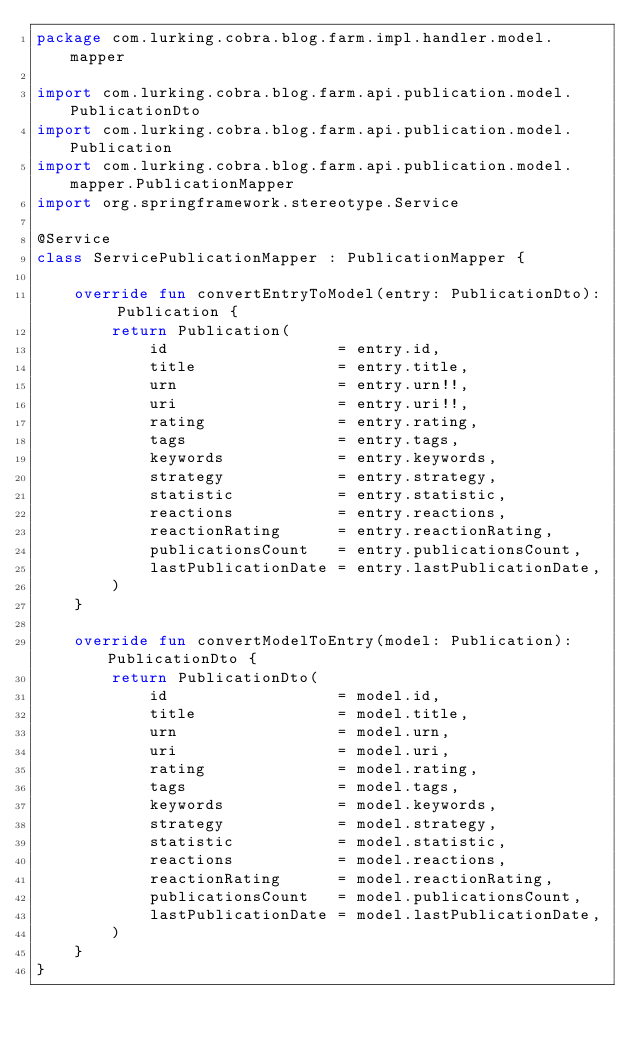<code> <loc_0><loc_0><loc_500><loc_500><_Kotlin_>package com.lurking.cobra.blog.farm.impl.handler.model.mapper

import com.lurking.cobra.blog.farm.api.publication.model.PublicationDto
import com.lurking.cobra.blog.farm.api.publication.model.Publication
import com.lurking.cobra.blog.farm.api.publication.model.mapper.PublicationMapper
import org.springframework.stereotype.Service

@Service
class ServicePublicationMapper : PublicationMapper {

    override fun convertEntryToModel(entry: PublicationDto): Publication {
        return Publication(
            id                  = entry.id,
            title               = entry.title,
            urn                 = entry.urn!!,
            uri                 = entry.uri!!,
            rating              = entry.rating,
            tags                = entry.tags,
            keywords            = entry.keywords,
            strategy            = entry.strategy,
            statistic           = entry.statistic,
            reactions           = entry.reactions,
            reactionRating      = entry.reactionRating,
            publicationsCount   = entry.publicationsCount,
            lastPublicationDate = entry.lastPublicationDate,
        )
    }

    override fun convertModelToEntry(model: Publication): PublicationDto {
        return PublicationDto(
            id                  = model.id,
            title               = model.title,
            urn                 = model.urn,
            uri                 = model.uri,
            rating              = model.rating,
            tags                = model.tags,
            keywords            = model.keywords,
            strategy            = model.strategy,
            statistic           = model.statistic,
            reactions           = model.reactions,
            reactionRating      = model.reactionRating,
            publicationsCount   = model.publicationsCount,
            lastPublicationDate = model.lastPublicationDate,
        )
    }
}</code> 